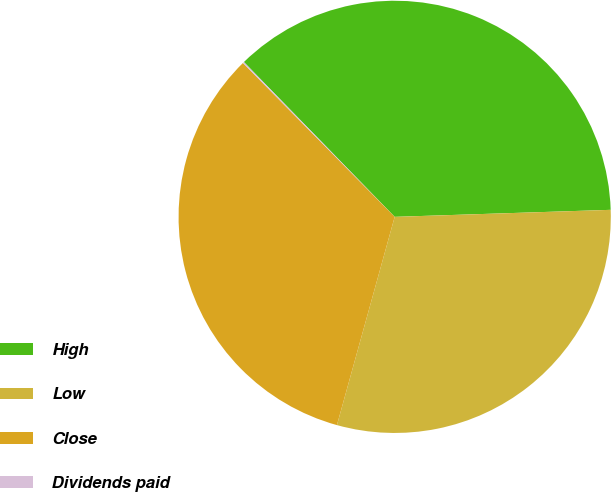Convert chart to OTSL. <chart><loc_0><loc_0><loc_500><loc_500><pie_chart><fcel>High<fcel>Low<fcel>Close<fcel>Dividends paid<nl><fcel>36.77%<fcel>29.82%<fcel>33.3%<fcel>0.1%<nl></chart> 